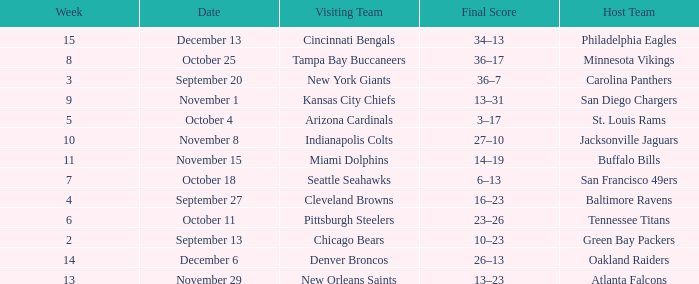Which week did the Baltimore Ravens play at home ? 4.0. 